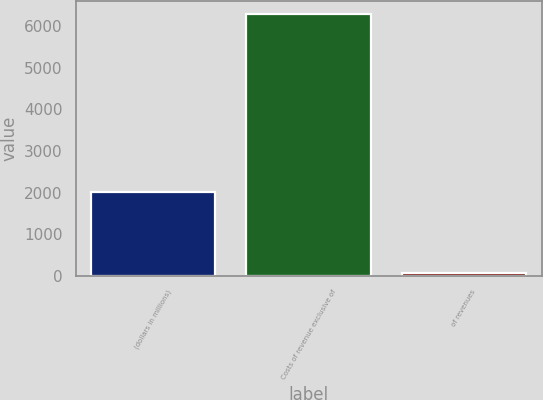Convert chart to OTSL. <chart><loc_0><loc_0><loc_500><loc_500><bar_chart><fcel>(dollars in millions)<fcel>Costs of revenue exclusive of<fcel>of revenues<nl><fcel>2017<fcel>6301<fcel>64.9<nl></chart> 